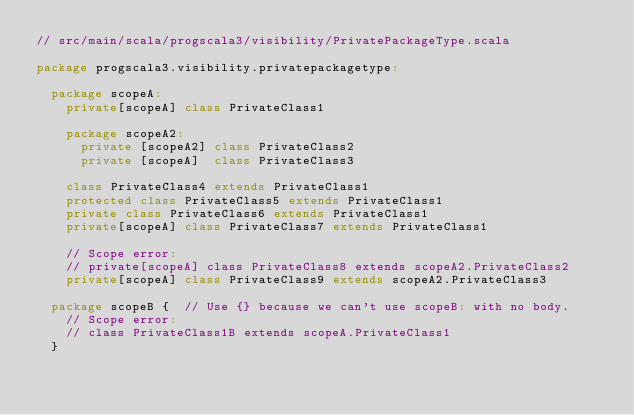Convert code to text. <code><loc_0><loc_0><loc_500><loc_500><_Scala_>// src/main/scala/progscala3/visibility/PrivatePackageType.scala

package progscala3.visibility.privatepackagetype:

  package scopeA:
    private[scopeA] class PrivateClass1

    package scopeA2:
      private [scopeA2] class PrivateClass2
      private [scopeA]  class PrivateClass3

    class PrivateClass4 extends PrivateClass1
    protected class PrivateClass5 extends PrivateClass1
    private class PrivateClass6 extends PrivateClass1
    private[scopeA] class PrivateClass7 extends PrivateClass1

    // Scope error:
    // private[scopeA] class PrivateClass8 extends scopeA2.PrivateClass2
    private[scopeA] class PrivateClass9 extends scopeA2.PrivateClass3

  package scopeB {  // Use {} because we can't use scopeB: with no body.
    // Scope error:
    // class PrivateClass1B extends scopeA.PrivateClass1
  }</code> 